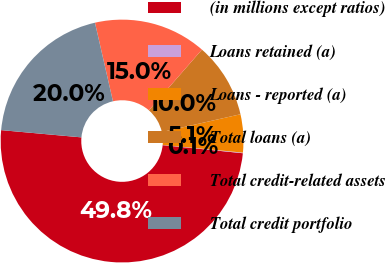Convert chart. <chart><loc_0><loc_0><loc_500><loc_500><pie_chart><fcel>(in millions except ratios)<fcel>Loans retained (a)<fcel>Loans - reported (a)<fcel>Total loans (a)<fcel>Total credit-related assets<fcel>Total credit portfolio<nl><fcel>49.83%<fcel>0.08%<fcel>5.06%<fcel>10.03%<fcel>15.01%<fcel>19.98%<nl></chart> 